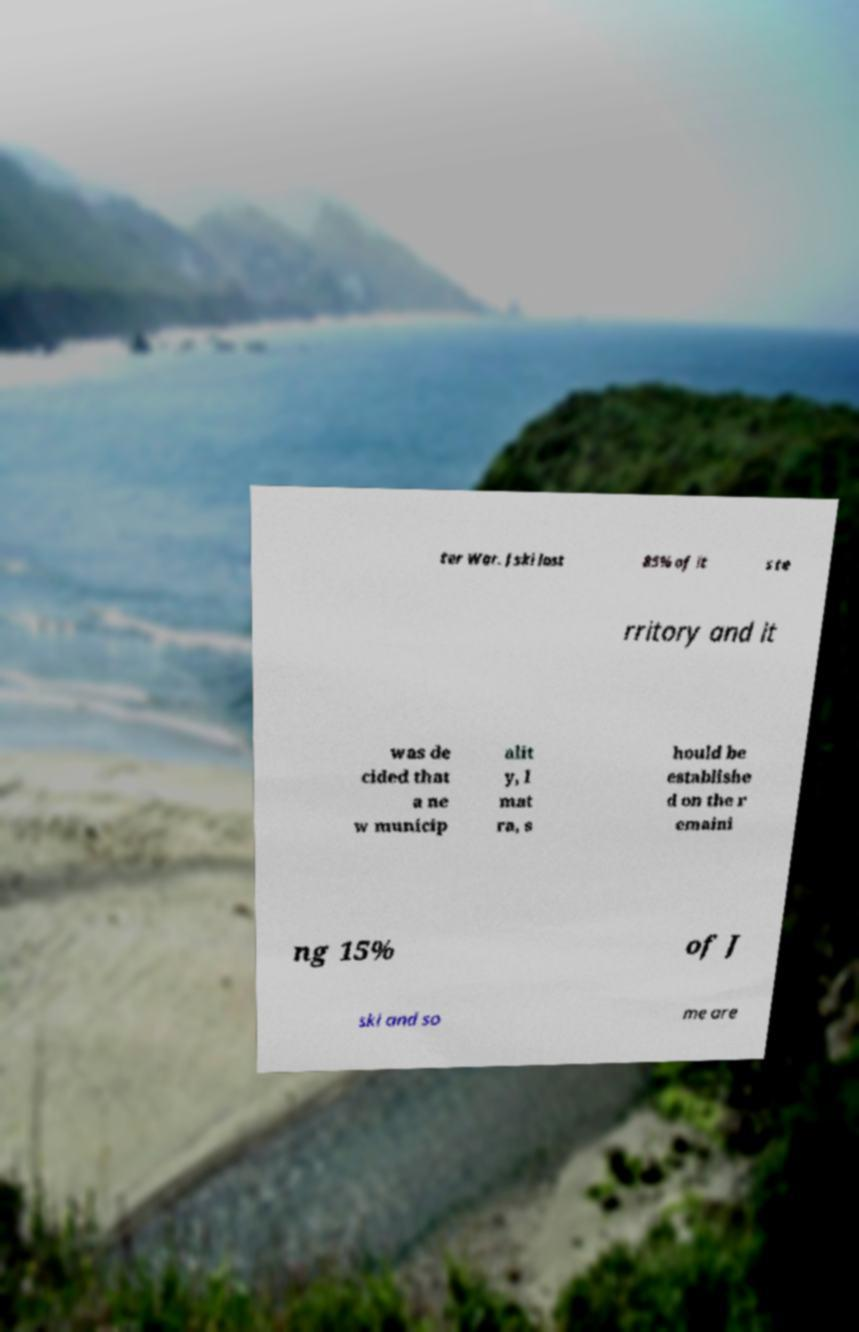Could you extract and type out the text from this image? ter War. Jski lost 85% of it s te rritory and it was de cided that a ne w municip alit y, I mat ra, s hould be establishe d on the r emaini ng 15% of J ski and so me are 